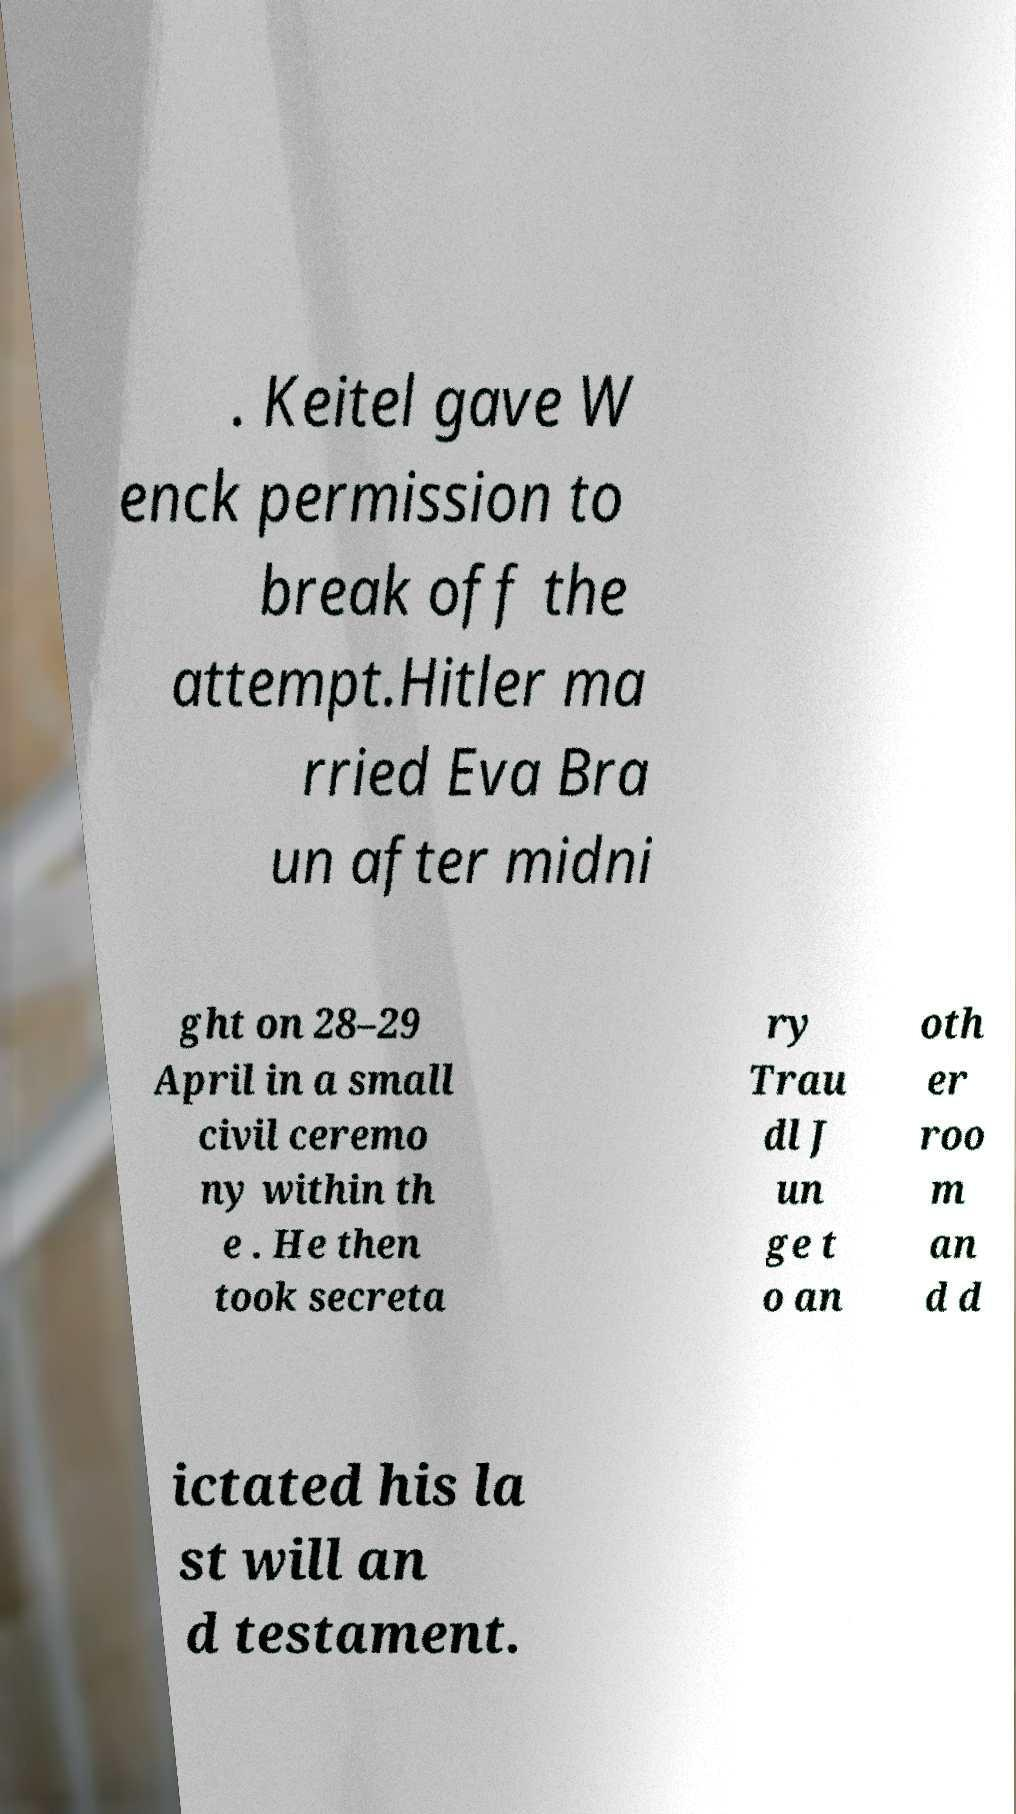Can you accurately transcribe the text from the provided image for me? . Keitel gave W enck permission to break off the attempt.Hitler ma rried Eva Bra un after midni ght on 28–29 April in a small civil ceremo ny within th e . He then took secreta ry Trau dl J un ge t o an oth er roo m an d d ictated his la st will an d testament. 